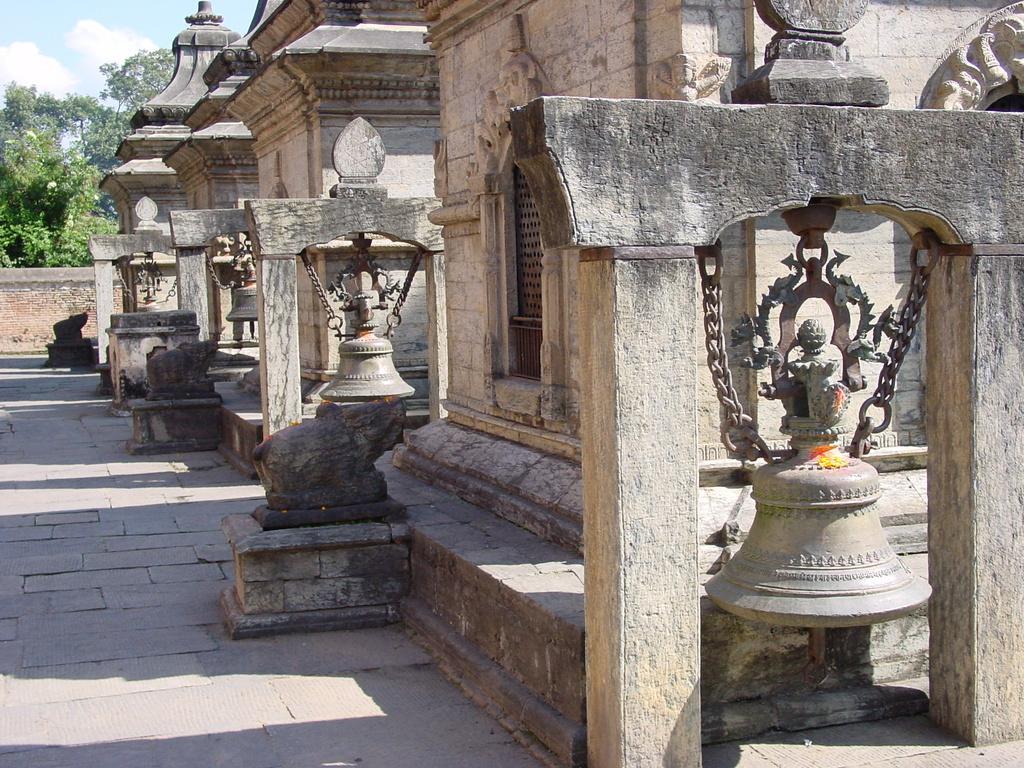Could you give a brief overview of what you see in this image? In this picture I can see the ancient building, few beers and the path in front. In the background I can see the trees and the sky. 